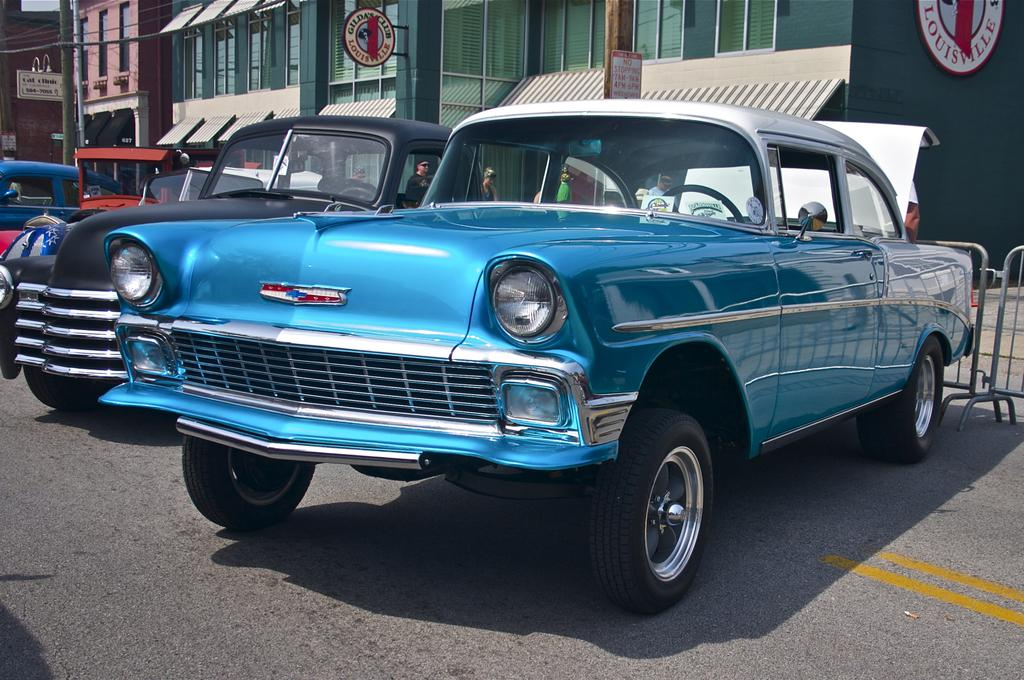What is happening on the road in the image? There are vehicles on the road in the image. What can be seen behind the vehicles? There is a fence behind the vehicles. What is visible in the distance in the image? There are buildings, hoardings, and poles in the background of the image. Are there any people visible in the image? Yes, there is a group of people in the background of the image. Can you see the arm of the robin in the image? There is no robin present in the image, so it is not possible to see its arm. 